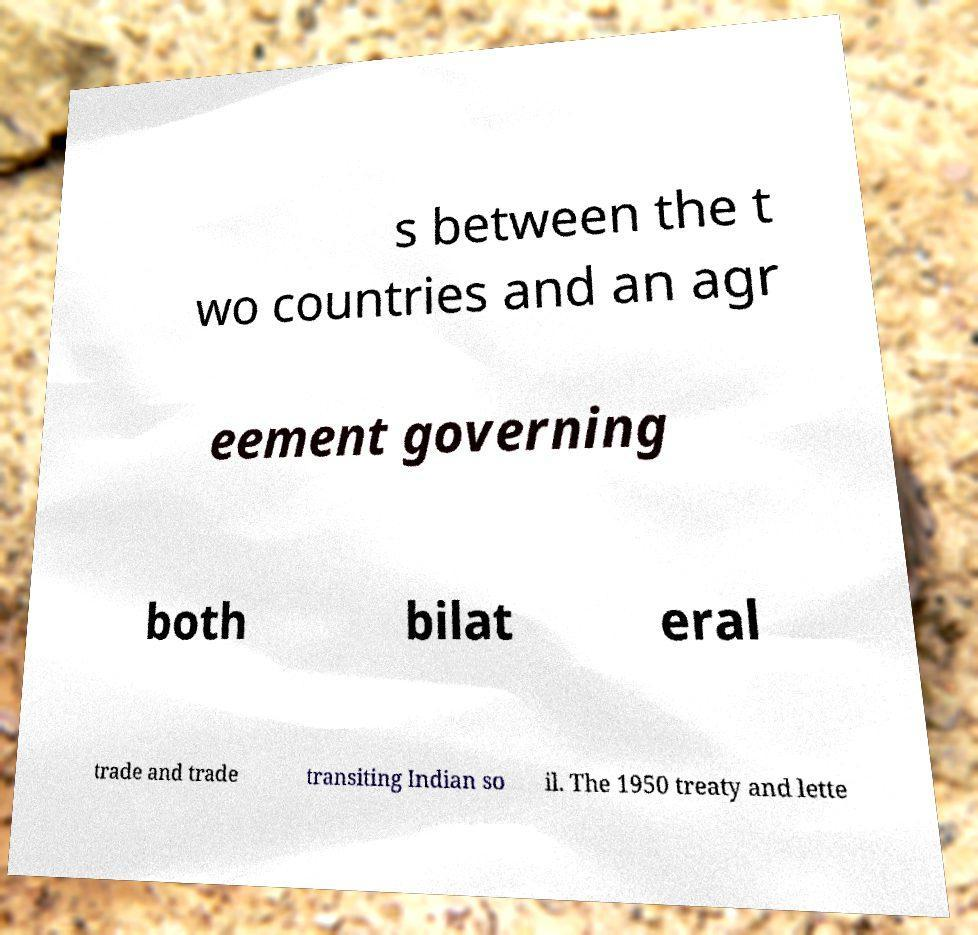I need the written content from this picture converted into text. Can you do that? s between the t wo countries and an agr eement governing both bilat eral trade and trade transiting Indian so il. The 1950 treaty and lette 